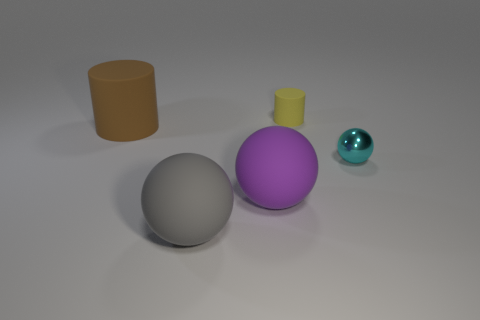Add 2 big green objects. How many objects exist? 7 Subtract all balls. How many objects are left? 2 Add 5 yellow matte cylinders. How many yellow matte cylinders exist? 6 Subtract 0 blue cylinders. How many objects are left? 5 Subtract all large red blocks. Subtract all big spheres. How many objects are left? 3 Add 3 purple rubber objects. How many purple rubber objects are left? 4 